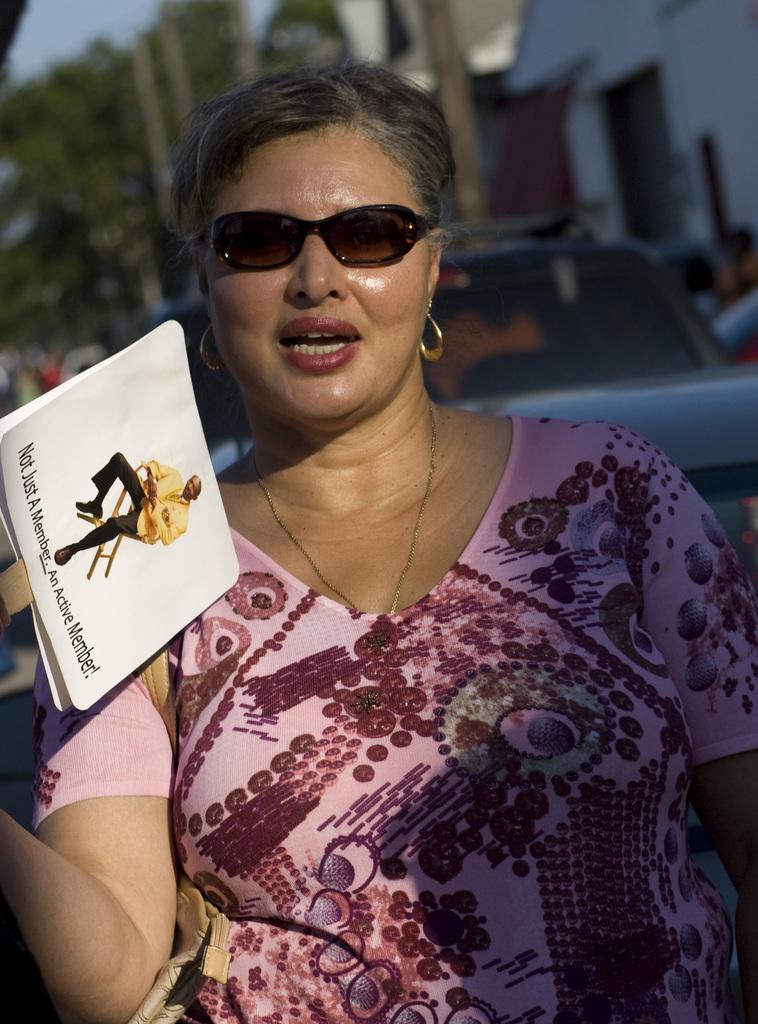Can you describe this image briefly? In this picture we can see a woman is holding a placard in the front, there is a picture of a person and some text on the placard, there is a car in the middle, in the background we can see trees and a house. 